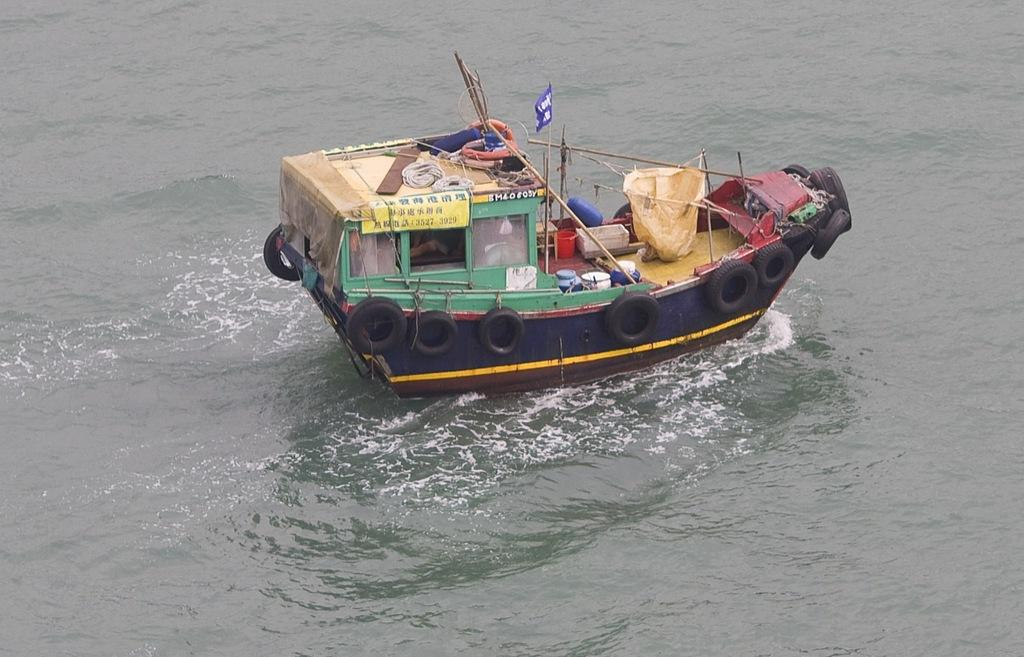What is at the bottom of the image? There is water at the bottom of the image. What is located in the middle of the image? There is a boat in the middle of the image. What objects can be seen in the image that are typically used for vehicles? Tyres are visible in the image. What items are present in the image that are used for tying or securing? There are ropes in the image. What can be seen in the image that represents a symbol or group? There is a flag in the image. What objects are present in the image that are long and thin? There are sticks in the image. What type of insect can be seen crawling on the flag in the image? There are no insects present in the image, and therefore no insects can be seen crawling on the flag. What type of creature is shown interacting with the boat in the image? There are no creatures shown interacting with the boat in the image; only the boat, water, tyres, ropes, flag, and sticks are present. 